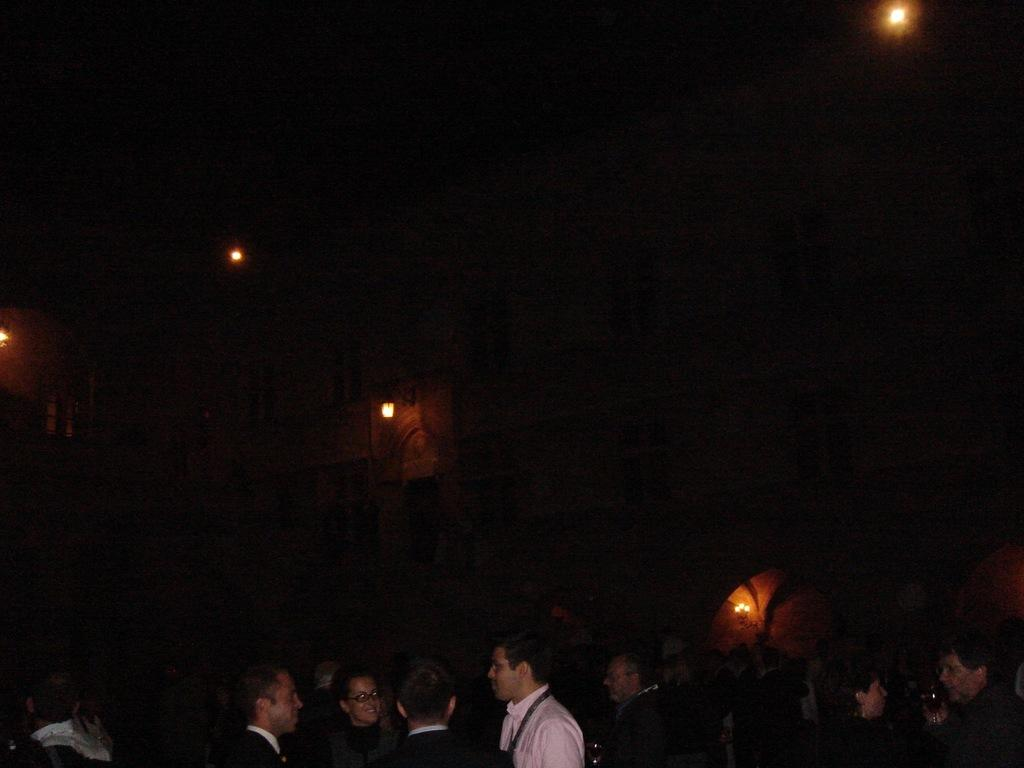What is happening in the image? There are people standing in the image. What can be seen in the background of the image? There are lights in the background of the image. How would you describe the overall lighting in the image? The background of the image is dark. What type of watch is the leaf wearing in the image? There is no watch or leaf present in the image. 